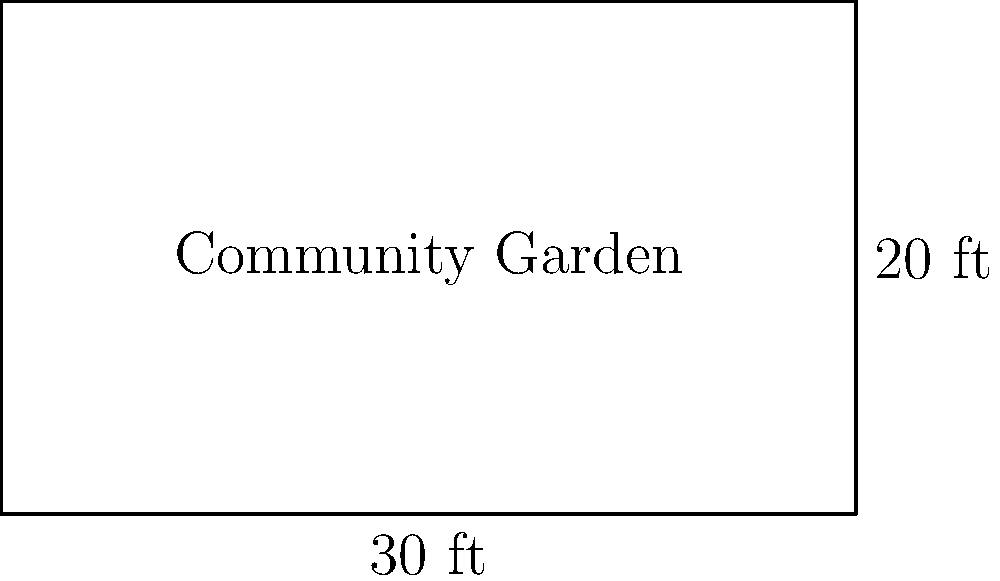As part of your community service initiative, you're planning a rectangular community garden. The plot measures 30 feet in length and 20 feet in width. What is the total area of the garden plot in square feet? To find the area of a rectangular plot, we need to multiply its length by its width. Let's break it down step by step:

1. Identify the given dimensions:
   - Length = 30 feet
   - Width = 20 feet

2. Use the formula for the area of a rectangle:
   $$ \text{Area} = \text{Length} \times \text{Width} $$

3. Substitute the values into the formula:
   $$ \text{Area} = 30 \text{ ft} \times 20 \text{ ft} $$

4. Perform the multiplication:
   $$ \text{Area} = 600 \text{ ft}^2 $$

Therefore, the total area of the community garden plot is 600 square feet.
Answer: $600 \text{ ft}^2$ 